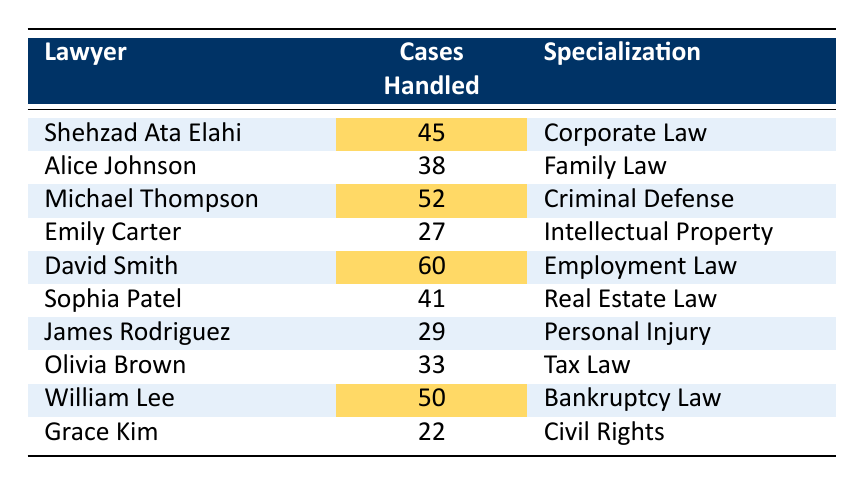What is the highest number of cases handled by a single lawyer? The table shows that David Smith handled the highest number of cases, which is 60.
Answer: 60 Which lawyer specializes in Criminal Defense? Michael Thompson is listed as the lawyer specializing in Criminal Defense and handled 52 cases.
Answer: Michael Thompson How many total cases were handled by all lawyers combined? Adding all the cases: 45 + 38 + 52 + 27 + 60 + 41 + 29 + 33 + 50 + 22 =  397.
Answer: 397 Is there a lawyer who handled fewer than 30 cases? Yes, Emily Carter handled 27 cases, which is fewer than 30.
Answer: Yes What is the average number of cases handled by the lawyers? To find the average, sum all cases (397) and divide by the number of lawyers (10): 397 / 10 = 39.7.
Answer: 39.7 Which lawyer handled the second-highest number of cases? The second-highest is William Lee with 50 cases. David Smith has the highest with 60 cases.
Answer: William Lee How many lawyers specialize in law fields related to property (Intellectual Property and Real Estate Law)? There are two lawyers: Emily Carter (Intellectual Property) and Sophia Patel (Real Estate Law).
Answer: 2 Was there a lawyer that handled more than 40 cases but less than 50 cases? Yes, Sophia Patel handled 41 cases, which fits this criterion.
Answer: Yes If you combine the number of cases handled by Shehzad Ata Elahi and Alice Johnson, how many cases do they handle in total? Adding cases handled by both: 45 (Shehzad) + 38 (Alice) = 83.
Answer: 83 Who handled more cases, James Rodriguez or Olivia Brown? James Rodriguez handled 29 cases, while Olivia Brown handled 33 cases. Since 33 is greater than 29, Olivia handled more.
Answer: Olivia Brown 